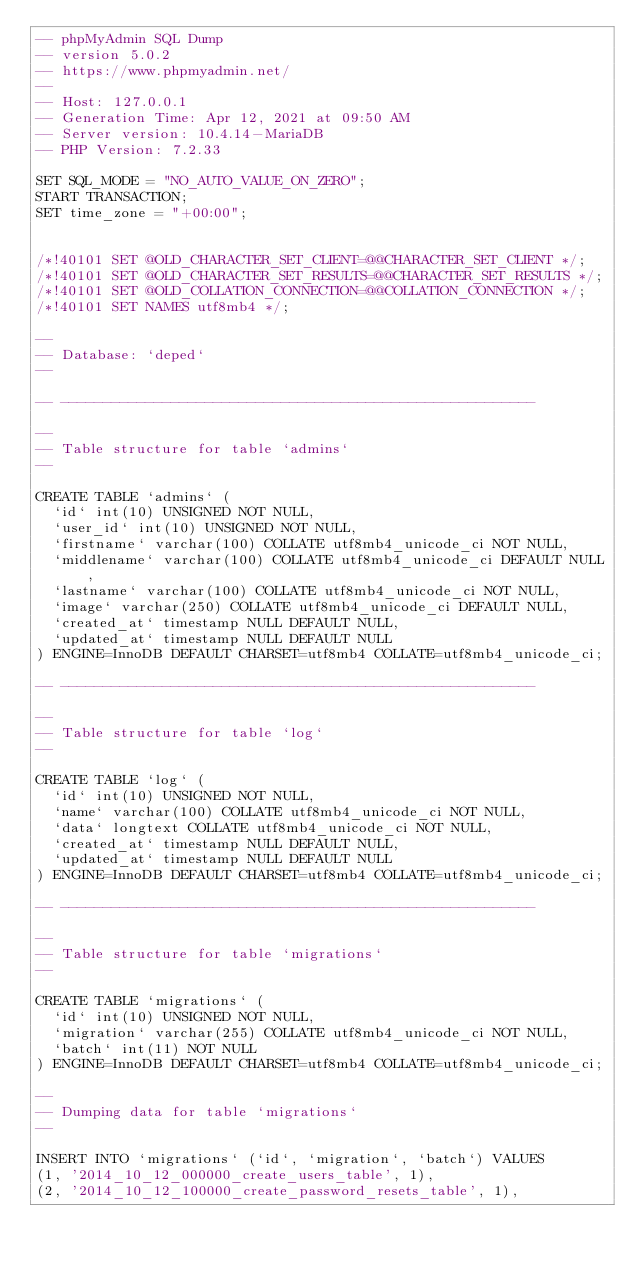Convert code to text. <code><loc_0><loc_0><loc_500><loc_500><_SQL_>-- phpMyAdmin SQL Dump
-- version 5.0.2
-- https://www.phpmyadmin.net/
--
-- Host: 127.0.0.1
-- Generation Time: Apr 12, 2021 at 09:50 AM
-- Server version: 10.4.14-MariaDB
-- PHP Version: 7.2.33

SET SQL_MODE = "NO_AUTO_VALUE_ON_ZERO";
START TRANSACTION;
SET time_zone = "+00:00";


/*!40101 SET @OLD_CHARACTER_SET_CLIENT=@@CHARACTER_SET_CLIENT */;
/*!40101 SET @OLD_CHARACTER_SET_RESULTS=@@CHARACTER_SET_RESULTS */;
/*!40101 SET @OLD_COLLATION_CONNECTION=@@COLLATION_CONNECTION */;
/*!40101 SET NAMES utf8mb4 */;

--
-- Database: `deped`
--

-- --------------------------------------------------------

--
-- Table structure for table `admins`
--

CREATE TABLE `admins` (
  `id` int(10) UNSIGNED NOT NULL,
  `user_id` int(10) UNSIGNED NOT NULL,
  `firstname` varchar(100) COLLATE utf8mb4_unicode_ci NOT NULL,
  `middlename` varchar(100) COLLATE utf8mb4_unicode_ci DEFAULT NULL,
  `lastname` varchar(100) COLLATE utf8mb4_unicode_ci NOT NULL,
  `image` varchar(250) COLLATE utf8mb4_unicode_ci DEFAULT NULL,
  `created_at` timestamp NULL DEFAULT NULL,
  `updated_at` timestamp NULL DEFAULT NULL
) ENGINE=InnoDB DEFAULT CHARSET=utf8mb4 COLLATE=utf8mb4_unicode_ci;

-- --------------------------------------------------------

--
-- Table structure for table `log`
--

CREATE TABLE `log` (
  `id` int(10) UNSIGNED NOT NULL,
  `name` varchar(100) COLLATE utf8mb4_unicode_ci NOT NULL,
  `data` longtext COLLATE utf8mb4_unicode_ci NOT NULL,
  `created_at` timestamp NULL DEFAULT NULL,
  `updated_at` timestamp NULL DEFAULT NULL
) ENGINE=InnoDB DEFAULT CHARSET=utf8mb4 COLLATE=utf8mb4_unicode_ci;

-- --------------------------------------------------------

--
-- Table structure for table `migrations`
--

CREATE TABLE `migrations` (
  `id` int(10) UNSIGNED NOT NULL,
  `migration` varchar(255) COLLATE utf8mb4_unicode_ci NOT NULL,
  `batch` int(11) NOT NULL
) ENGINE=InnoDB DEFAULT CHARSET=utf8mb4 COLLATE=utf8mb4_unicode_ci;

--
-- Dumping data for table `migrations`
--

INSERT INTO `migrations` (`id`, `migration`, `batch`) VALUES
(1, '2014_10_12_000000_create_users_table', 1),
(2, '2014_10_12_100000_create_password_resets_table', 1),</code> 